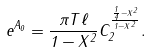Convert formula to latex. <formula><loc_0><loc_0><loc_500><loc_500>e ^ { A _ { 0 } } = \frac { \pi T \ell } { 1 - X ^ { 2 } } C _ { 2 } ^ { \frac { \frac { 1 } { 4 } - X ^ { 2 } } { 1 - X ^ { 2 } } } .</formula> 